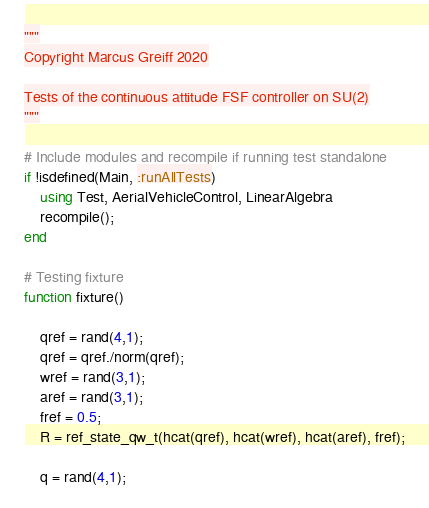Convert code to text. <code><loc_0><loc_0><loc_500><loc_500><_Julia_>"""
Copyright Marcus Greiff 2020

Tests of the continuous attitude FSF controller on SU(2)
"""

# Include modules and recompile if running test standalone
if !isdefined(Main, :runAllTests)
    using Test, AerialVehicleControl, LinearAlgebra
    recompile();
end

# Testing fixture
function fixture()

    qref = rand(4,1);
    qref = qref./norm(qref);
    wref = rand(3,1);
    aref = rand(3,1);
    fref = 0.5;
    R = ref_state_qw_t(hcat(qref), hcat(wref), hcat(aref), fref);

    q = rand(4,1);</code> 